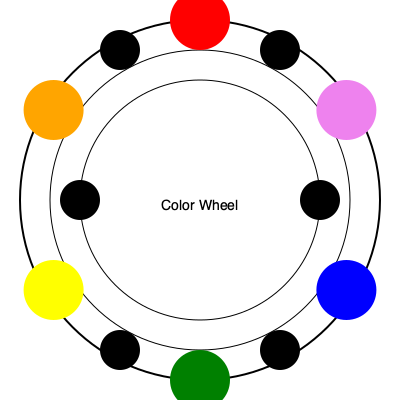In a romantic comedy set in a vibrant coastal town, you're designing a costume for the quirky female lead who's a marine biologist. Using the color wheel, which complementary color combination would best represent her profession and the seaside setting, while also creating visual interest for her character? To answer this question, we need to consider several factors:

1. Color Theory: Complementary colors are located opposite each other on the color wheel. They create high contrast and visual interest when used together.

2. Profession representation: As a marine biologist, blue would be an appropriate color to represent the ocean and her field of study.

3. Seaside setting: Blue also represents the coastal environment, while yellow could represent the sun and sand.

4. Visual interest: Complementary colors create a striking contrast, which is ideal for a quirky character in a romantic comedy.

5. Color wheel analysis: Looking at the color wheel, we can see that blue and yellow are complementary colors, positioned opposite each other.

6. Character portrayal: The blue-yellow combination not only represents the setting and profession but also creates a visually interesting and memorable costume, perfect for a quirky lead character.

7. Practical application: This color combination could be used in various ways, such as a yellow dress with blue accessories or a blue outfit with yellow accents, allowing for creativity in costume design.

Therefore, the best complementary color combination for this character would be blue and yellow, as it fulfills all the required criteria while creating a visually appealing costume design.
Answer: Blue and yellow 